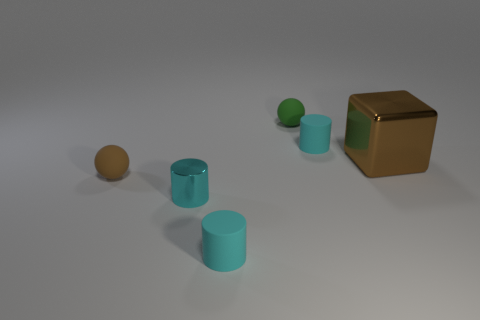Comparing the sizes, can you tell which object is the largest and which is the smallest? Assessing the objects relative to one another in the image, the brown cube appears to be the largest object present. In contrast, the green ball situated near the cube seems to be the smallest item in the collection. The three cylinders and the tan ball fall in between these two extremes, with the cylinders being relatively similar in size and the tan ball being slightly smaller. 